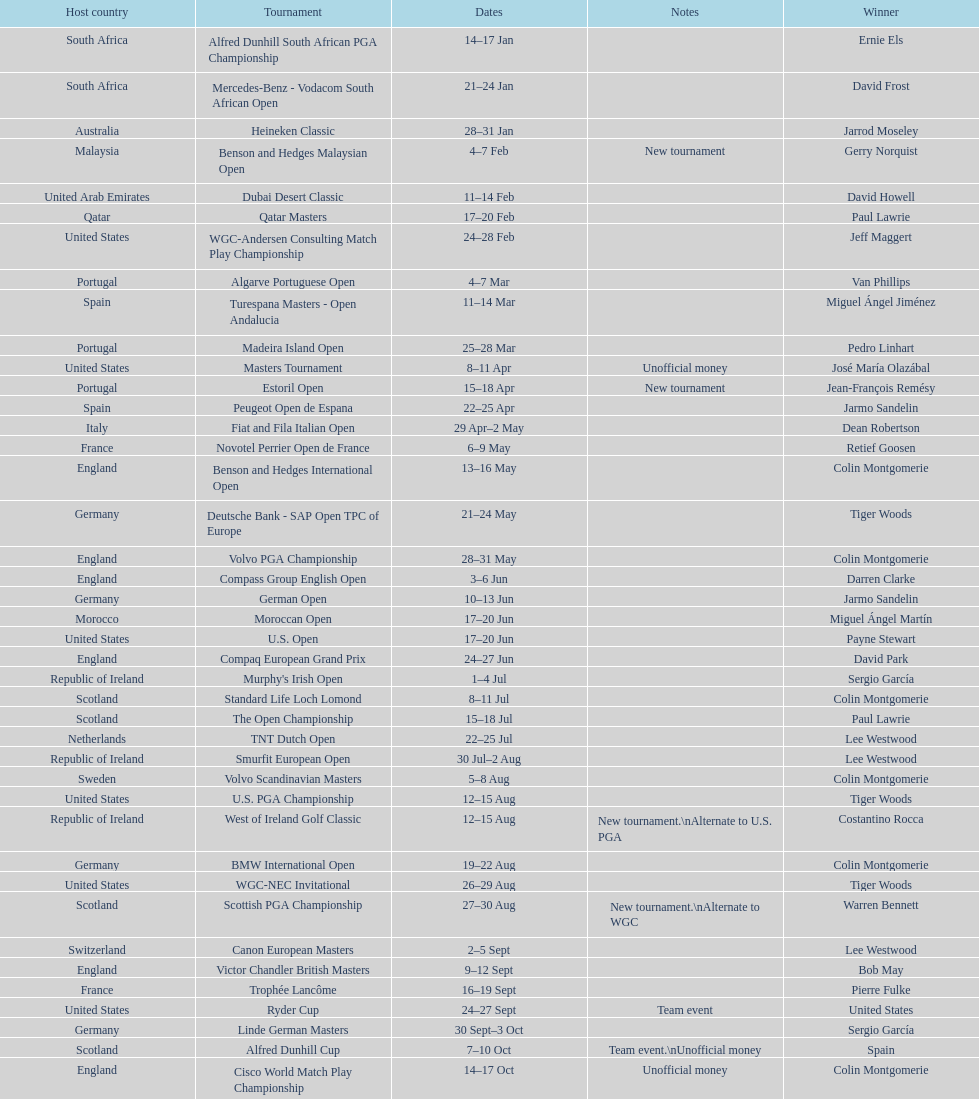Which winner won more tournaments, jeff maggert or tiger woods? Tiger Woods. 